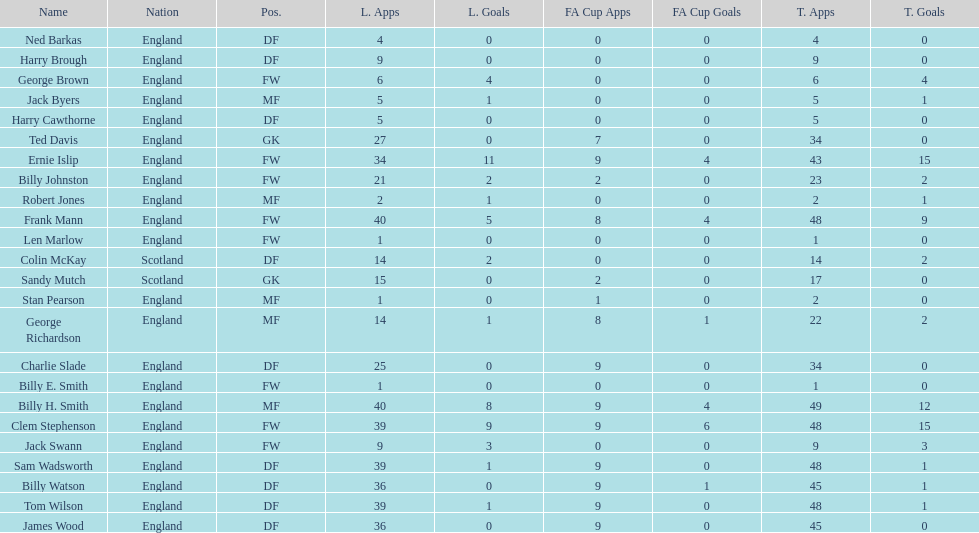Name the nation with the most appearances. England. 